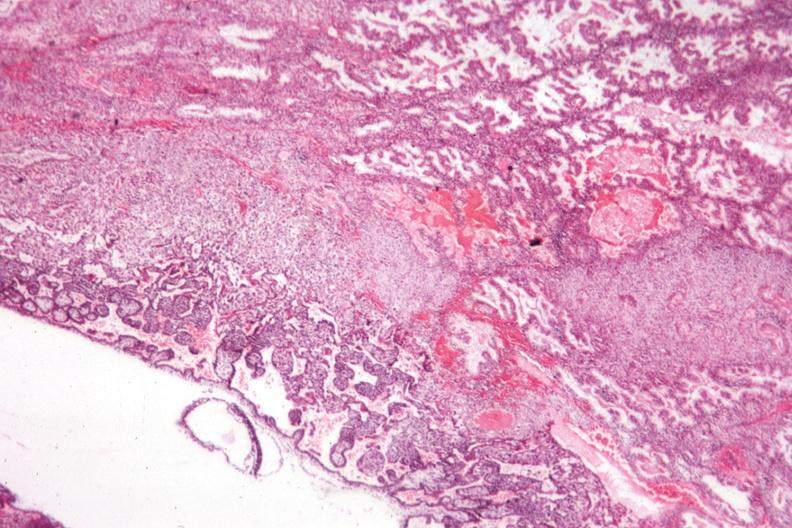what is present?
Answer the question using a single word or phrase. Fetus developing very early 